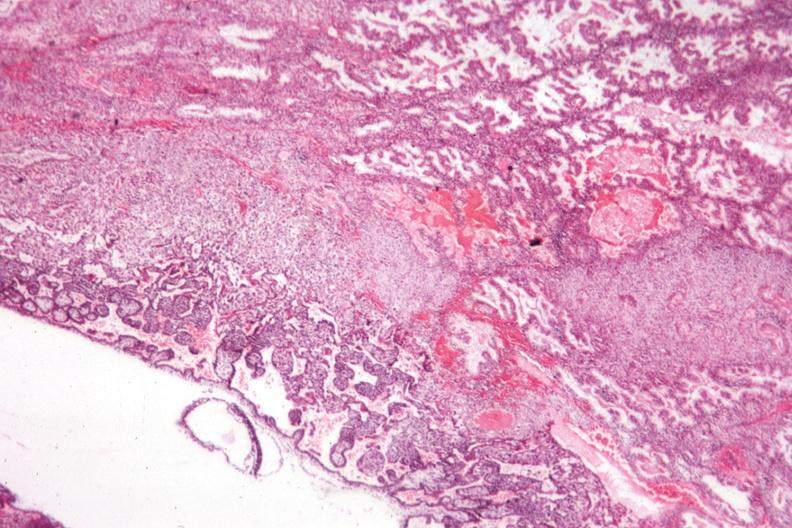what is present?
Answer the question using a single word or phrase. Fetus developing very early 